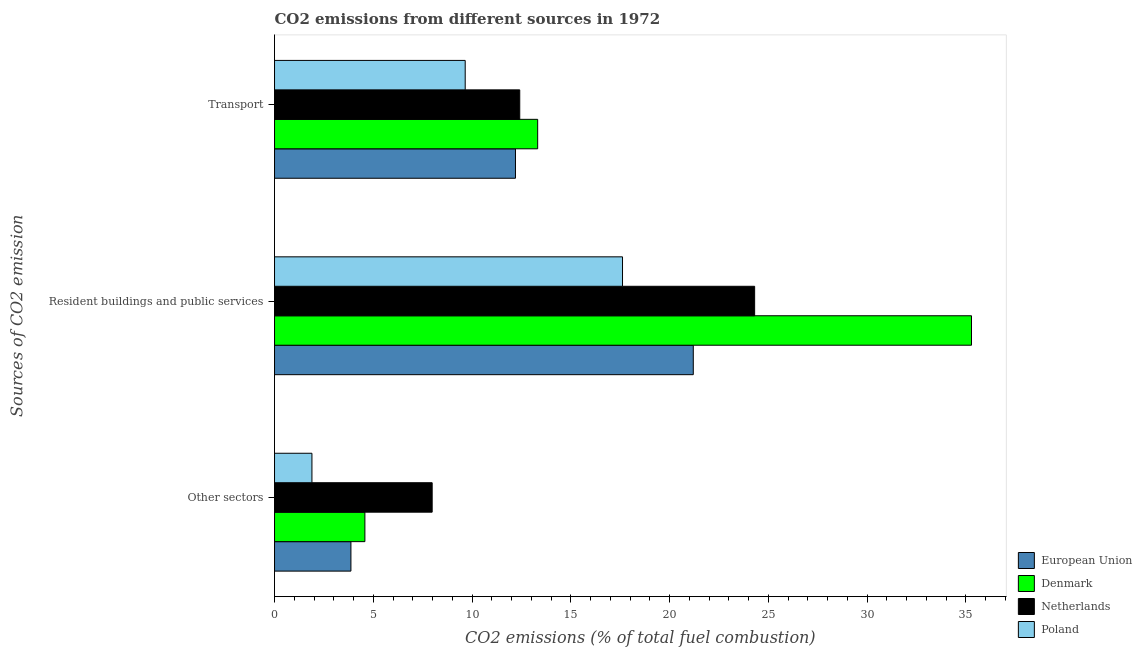How many groups of bars are there?
Provide a short and direct response. 3. Are the number of bars on each tick of the Y-axis equal?
Offer a very short reply. Yes. How many bars are there on the 3rd tick from the top?
Make the answer very short. 4. What is the label of the 1st group of bars from the top?
Your answer should be very brief. Transport. What is the percentage of co2 emissions from transport in European Union?
Ensure brevity in your answer.  12.2. Across all countries, what is the maximum percentage of co2 emissions from other sectors?
Your answer should be compact. 7.98. Across all countries, what is the minimum percentage of co2 emissions from other sectors?
Your answer should be compact. 1.89. What is the total percentage of co2 emissions from other sectors in the graph?
Give a very brief answer. 18.32. What is the difference between the percentage of co2 emissions from transport in Poland and that in Denmark?
Provide a short and direct response. -3.67. What is the difference between the percentage of co2 emissions from resident buildings and public services in European Union and the percentage of co2 emissions from other sectors in Denmark?
Ensure brevity in your answer.  16.62. What is the average percentage of co2 emissions from resident buildings and public services per country?
Your answer should be compact. 24.6. What is the difference between the percentage of co2 emissions from other sectors and percentage of co2 emissions from transport in European Union?
Offer a very short reply. -8.33. In how many countries, is the percentage of co2 emissions from transport greater than 6 %?
Your answer should be very brief. 4. What is the ratio of the percentage of co2 emissions from transport in Poland to that in European Union?
Ensure brevity in your answer.  0.79. Is the percentage of co2 emissions from other sectors in Poland less than that in European Union?
Provide a short and direct response. Yes. Is the difference between the percentage of co2 emissions from transport in Denmark and European Union greater than the difference between the percentage of co2 emissions from resident buildings and public services in Denmark and European Union?
Your answer should be very brief. No. What is the difference between the highest and the second highest percentage of co2 emissions from other sectors?
Give a very brief answer. 3.41. What is the difference between the highest and the lowest percentage of co2 emissions from other sectors?
Offer a very short reply. 6.09. How many bars are there?
Offer a very short reply. 12. Are all the bars in the graph horizontal?
Provide a succinct answer. Yes. What is the difference between two consecutive major ticks on the X-axis?
Your answer should be compact. 5. Are the values on the major ticks of X-axis written in scientific E-notation?
Keep it short and to the point. No. Does the graph contain grids?
Make the answer very short. No. Where does the legend appear in the graph?
Keep it short and to the point. Bottom right. What is the title of the graph?
Your response must be concise. CO2 emissions from different sources in 1972. What is the label or title of the X-axis?
Ensure brevity in your answer.  CO2 emissions (% of total fuel combustion). What is the label or title of the Y-axis?
Your response must be concise. Sources of CO2 emission. What is the CO2 emissions (% of total fuel combustion) in European Union in Other sectors?
Provide a succinct answer. 3.87. What is the CO2 emissions (% of total fuel combustion) of Denmark in Other sectors?
Your response must be concise. 4.57. What is the CO2 emissions (% of total fuel combustion) in Netherlands in Other sectors?
Your response must be concise. 7.98. What is the CO2 emissions (% of total fuel combustion) of Poland in Other sectors?
Offer a terse response. 1.89. What is the CO2 emissions (% of total fuel combustion) of European Union in Resident buildings and public services?
Ensure brevity in your answer.  21.2. What is the CO2 emissions (% of total fuel combustion) in Denmark in Resident buildings and public services?
Provide a succinct answer. 35.28. What is the CO2 emissions (% of total fuel combustion) of Netherlands in Resident buildings and public services?
Offer a very short reply. 24.31. What is the CO2 emissions (% of total fuel combustion) of Poland in Resident buildings and public services?
Make the answer very short. 17.62. What is the CO2 emissions (% of total fuel combustion) of European Union in Transport?
Ensure brevity in your answer.  12.2. What is the CO2 emissions (% of total fuel combustion) of Denmark in Transport?
Offer a terse response. 13.32. What is the CO2 emissions (% of total fuel combustion) of Netherlands in Transport?
Offer a very short reply. 12.41. What is the CO2 emissions (% of total fuel combustion) in Poland in Transport?
Your response must be concise. 9.65. Across all Sources of CO2 emission, what is the maximum CO2 emissions (% of total fuel combustion) in European Union?
Make the answer very short. 21.2. Across all Sources of CO2 emission, what is the maximum CO2 emissions (% of total fuel combustion) of Denmark?
Your answer should be compact. 35.28. Across all Sources of CO2 emission, what is the maximum CO2 emissions (% of total fuel combustion) of Netherlands?
Your response must be concise. 24.31. Across all Sources of CO2 emission, what is the maximum CO2 emissions (% of total fuel combustion) in Poland?
Your answer should be very brief. 17.62. Across all Sources of CO2 emission, what is the minimum CO2 emissions (% of total fuel combustion) in European Union?
Your answer should be compact. 3.87. Across all Sources of CO2 emission, what is the minimum CO2 emissions (% of total fuel combustion) in Denmark?
Offer a very short reply. 4.57. Across all Sources of CO2 emission, what is the minimum CO2 emissions (% of total fuel combustion) in Netherlands?
Make the answer very short. 7.98. Across all Sources of CO2 emission, what is the minimum CO2 emissions (% of total fuel combustion) in Poland?
Offer a terse response. 1.89. What is the total CO2 emissions (% of total fuel combustion) in European Union in the graph?
Your response must be concise. 37.26. What is the total CO2 emissions (% of total fuel combustion) of Denmark in the graph?
Provide a short and direct response. 53.18. What is the total CO2 emissions (% of total fuel combustion) in Netherlands in the graph?
Offer a terse response. 44.7. What is the total CO2 emissions (% of total fuel combustion) of Poland in the graph?
Make the answer very short. 29.16. What is the difference between the CO2 emissions (% of total fuel combustion) of European Union in Other sectors and that in Resident buildings and public services?
Your answer should be compact. -17.33. What is the difference between the CO2 emissions (% of total fuel combustion) in Denmark in Other sectors and that in Resident buildings and public services?
Provide a succinct answer. -30.71. What is the difference between the CO2 emissions (% of total fuel combustion) of Netherlands in Other sectors and that in Resident buildings and public services?
Your answer should be very brief. -16.33. What is the difference between the CO2 emissions (% of total fuel combustion) in Poland in Other sectors and that in Resident buildings and public services?
Make the answer very short. -15.72. What is the difference between the CO2 emissions (% of total fuel combustion) in European Union in Other sectors and that in Transport?
Your response must be concise. -8.33. What is the difference between the CO2 emissions (% of total fuel combustion) in Denmark in Other sectors and that in Transport?
Offer a very short reply. -8.75. What is the difference between the CO2 emissions (% of total fuel combustion) in Netherlands in Other sectors and that in Transport?
Provide a short and direct response. -4.43. What is the difference between the CO2 emissions (% of total fuel combustion) in Poland in Other sectors and that in Transport?
Keep it short and to the point. -7.76. What is the difference between the CO2 emissions (% of total fuel combustion) in European Union in Resident buildings and public services and that in Transport?
Offer a terse response. 9. What is the difference between the CO2 emissions (% of total fuel combustion) of Denmark in Resident buildings and public services and that in Transport?
Your answer should be very brief. 21.96. What is the difference between the CO2 emissions (% of total fuel combustion) in Netherlands in Resident buildings and public services and that in Transport?
Keep it short and to the point. 11.89. What is the difference between the CO2 emissions (% of total fuel combustion) in Poland in Resident buildings and public services and that in Transport?
Your response must be concise. 7.96. What is the difference between the CO2 emissions (% of total fuel combustion) in European Union in Other sectors and the CO2 emissions (% of total fuel combustion) in Denmark in Resident buildings and public services?
Ensure brevity in your answer.  -31.42. What is the difference between the CO2 emissions (% of total fuel combustion) in European Union in Other sectors and the CO2 emissions (% of total fuel combustion) in Netherlands in Resident buildings and public services?
Provide a short and direct response. -20.44. What is the difference between the CO2 emissions (% of total fuel combustion) of European Union in Other sectors and the CO2 emissions (% of total fuel combustion) of Poland in Resident buildings and public services?
Your answer should be very brief. -13.75. What is the difference between the CO2 emissions (% of total fuel combustion) of Denmark in Other sectors and the CO2 emissions (% of total fuel combustion) of Netherlands in Resident buildings and public services?
Give a very brief answer. -19.73. What is the difference between the CO2 emissions (% of total fuel combustion) in Denmark in Other sectors and the CO2 emissions (% of total fuel combustion) in Poland in Resident buildings and public services?
Make the answer very short. -13.04. What is the difference between the CO2 emissions (% of total fuel combustion) of Netherlands in Other sectors and the CO2 emissions (% of total fuel combustion) of Poland in Resident buildings and public services?
Your response must be concise. -9.64. What is the difference between the CO2 emissions (% of total fuel combustion) of European Union in Other sectors and the CO2 emissions (% of total fuel combustion) of Denmark in Transport?
Your answer should be compact. -9.45. What is the difference between the CO2 emissions (% of total fuel combustion) of European Union in Other sectors and the CO2 emissions (% of total fuel combustion) of Netherlands in Transport?
Offer a very short reply. -8.55. What is the difference between the CO2 emissions (% of total fuel combustion) of European Union in Other sectors and the CO2 emissions (% of total fuel combustion) of Poland in Transport?
Give a very brief answer. -5.79. What is the difference between the CO2 emissions (% of total fuel combustion) in Denmark in Other sectors and the CO2 emissions (% of total fuel combustion) in Netherlands in Transport?
Make the answer very short. -7.84. What is the difference between the CO2 emissions (% of total fuel combustion) of Denmark in Other sectors and the CO2 emissions (% of total fuel combustion) of Poland in Transport?
Ensure brevity in your answer.  -5.08. What is the difference between the CO2 emissions (% of total fuel combustion) of Netherlands in Other sectors and the CO2 emissions (% of total fuel combustion) of Poland in Transport?
Ensure brevity in your answer.  -1.67. What is the difference between the CO2 emissions (% of total fuel combustion) in European Union in Resident buildings and public services and the CO2 emissions (% of total fuel combustion) in Denmark in Transport?
Provide a short and direct response. 7.88. What is the difference between the CO2 emissions (% of total fuel combustion) in European Union in Resident buildings and public services and the CO2 emissions (% of total fuel combustion) in Netherlands in Transport?
Offer a very short reply. 8.79. What is the difference between the CO2 emissions (% of total fuel combustion) of European Union in Resident buildings and public services and the CO2 emissions (% of total fuel combustion) of Poland in Transport?
Offer a terse response. 11.55. What is the difference between the CO2 emissions (% of total fuel combustion) in Denmark in Resident buildings and public services and the CO2 emissions (% of total fuel combustion) in Netherlands in Transport?
Offer a terse response. 22.87. What is the difference between the CO2 emissions (% of total fuel combustion) in Denmark in Resident buildings and public services and the CO2 emissions (% of total fuel combustion) in Poland in Transport?
Ensure brevity in your answer.  25.63. What is the difference between the CO2 emissions (% of total fuel combustion) in Netherlands in Resident buildings and public services and the CO2 emissions (% of total fuel combustion) in Poland in Transport?
Your answer should be compact. 14.65. What is the average CO2 emissions (% of total fuel combustion) of European Union per Sources of CO2 emission?
Your answer should be very brief. 12.42. What is the average CO2 emissions (% of total fuel combustion) of Denmark per Sources of CO2 emission?
Give a very brief answer. 17.73. What is the average CO2 emissions (% of total fuel combustion) in Netherlands per Sources of CO2 emission?
Offer a terse response. 14.9. What is the average CO2 emissions (% of total fuel combustion) in Poland per Sources of CO2 emission?
Your answer should be compact. 9.72. What is the difference between the CO2 emissions (% of total fuel combustion) of European Union and CO2 emissions (% of total fuel combustion) of Denmark in Other sectors?
Keep it short and to the point. -0.71. What is the difference between the CO2 emissions (% of total fuel combustion) in European Union and CO2 emissions (% of total fuel combustion) in Netherlands in Other sectors?
Provide a succinct answer. -4.11. What is the difference between the CO2 emissions (% of total fuel combustion) of European Union and CO2 emissions (% of total fuel combustion) of Poland in Other sectors?
Offer a very short reply. 1.97. What is the difference between the CO2 emissions (% of total fuel combustion) in Denmark and CO2 emissions (% of total fuel combustion) in Netherlands in Other sectors?
Offer a terse response. -3.41. What is the difference between the CO2 emissions (% of total fuel combustion) of Denmark and CO2 emissions (% of total fuel combustion) of Poland in Other sectors?
Provide a short and direct response. 2.68. What is the difference between the CO2 emissions (% of total fuel combustion) of Netherlands and CO2 emissions (% of total fuel combustion) of Poland in Other sectors?
Your answer should be compact. 6.09. What is the difference between the CO2 emissions (% of total fuel combustion) in European Union and CO2 emissions (% of total fuel combustion) in Denmark in Resident buildings and public services?
Your answer should be compact. -14.09. What is the difference between the CO2 emissions (% of total fuel combustion) in European Union and CO2 emissions (% of total fuel combustion) in Netherlands in Resident buildings and public services?
Give a very brief answer. -3.11. What is the difference between the CO2 emissions (% of total fuel combustion) of European Union and CO2 emissions (% of total fuel combustion) of Poland in Resident buildings and public services?
Provide a short and direct response. 3.58. What is the difference between the CO2 emissions (% of total fuel combustion) of Denmark and CO2 emissions (% of total fuel combustion) of Netherlands in Resident buildings and public services?
Ensure brevity in your answer.  10.98. What is the difference between the CO2 emissions (% of total fuel combustion) in Denmark and CO2 emissions (% of total fuel combustion) in Poland in Resident buildings and public services?
Offer a terse response. 17.67. What is the difference between the CO2 emissions (% of total fuel combustion) in Netherlands and CO2 emissions (% of total fuel combustion) in Poland in Resident buildings and public services?
Provide a short and direct response. 6.69. What is the difference between the CO2 emissions (% of total fuel combustion) of European Union and CO2 emissions (% of total fuel combustion) of Denmark in Transport?
Ensure brevity in your answer.  -1.12. What is the difference between the CO2 emissions (% of total fuel combustion) of European Union and CO2 emissions (% of total fuel combustion) of Netherlands in Transport?
Your response must be concise. -0.22. What is the difference between the CO2 emissions (% of total fuel combustion) of European Union and CO2 emissions (% of total fuel combustion) of Poland in Transport?
Provide a succinct answer. 2.54. What is the difference between the CO2 emissions (% of total fuel combustion) in Denmark and CO2 emissions (% of total fuel combustion) in Netherlands in Transport?
Your answer should be very brief. 0.91. What is the difference between the CO2 emissions (% of total fuel combustion) in Denmark and CO2 emissions (% of total fuel combustion) in Poland in Transport?
Your answer should be very brief. 3.67. What is the difference between the CO2 emissions (% of total fuel combustion) in Netherlands and CO2 emissions (% of total fuel combustion) in Poland in Transport?
Your response must be concise. 2.76. What is the ratio of the CO2 emissions (% of total fuel combustion) of European Union in Other sectors to that in Resident buildings and public services?
Your response must be concise. 0.18. What is the ratio of the CO2 emissions (% of total fuel combustion) of Denmark in Other sectors to that in Resident buildings and public services?
Your response must be concise. 0.13. What is the ratio of the CO2 emissions (% of total fuel combustion) of Netherlands in Other sectors to that in Resident buildings and public services?
Offer a very short reply. 0.33. What is the ratio of the CO2 emissions (% of total fuel combustion) of Poland in Other sectors to that in Resident buildings and public services?
Offer a very short reply. 0.11. What is the ratio of the CO2 emissions (% of total fuel combustion) in European Union in Other sectors to that in Transport?
Provide a short and direct response. 0.32. What is the ratio of the CO2 emissions (% of total fuel combustion) in Denmark in Other sectors to that in Transport?
Ensure brevity in your answer.  0.34. What is the ratio of the CO2 emissions (% of total fuel combustion) in Netherlands in Other sectors to that in Transport?
Your response must be concise. 0.64. What is the ratio of the CO2 emissions (% of total fuel combustion) in Poland in Other sectors to that in Transport?
Provide a short and direct response. 0.2. What is the ratio of the CO2 emissions (% of total fuel combustion) of European Union in Resident buildings and public services to that in Transport?
Provide a succinct answer. 1.74. What is the ratio of the CO2 emissions (% of total fuel combustion) of Denmark in Resident buildings and public services to that in Transport?
Make the answer very short. 2.65. What is the ratio of the CO2 emissions (% of total fuel combustion) of Netherlands in Resident buildings and public services to that in Transport?
Ensure brevity in your answer.  1.96. What is the ratio of the CO2 emissions (% of total fuel combustion) of Poland in Resident buildings and public services to that in Transport?
Your answer should be very brief. 1.82. What is the difference between the highest and the second highest CO2 emissions (% of total fuel combustion) of European Union?
Provide a succinct answer. 9. What is the difference between the highest and the second highest CO2 emissions (% of total fuel combustion) of Denmark?
Offer a very short reply. 21.96. What is the difference between the highest and the second highest CO2 emissions (% of total fuel combustion) of Netherlands?
Your answer should be compact. 11.89. What is the difference between the highest and the second highest CO2 emissions (% of total fuel combustion) in Poland?
Offer a terse response. 7.96. What is the difference between the highest and the lowest CO2 emissions (% of total fuel combustion) of European Union?
Offer a terse response. 17.33. What is the difference between the highest and the lowest CO2 emissions (% of total fuel combustion) of Denmark?
Ensure brevity in your answer.  30.71. What is the difference between the highest and the lowest CO2 emissions (% of total fuel combustion) in Netherlands?
Your answer should be very brief. 16.33. What is the difference between the highest and the lowest CO2 emissions (% of total fuel combustion) in Poland?
Provide a short and direct response. 15.72. 